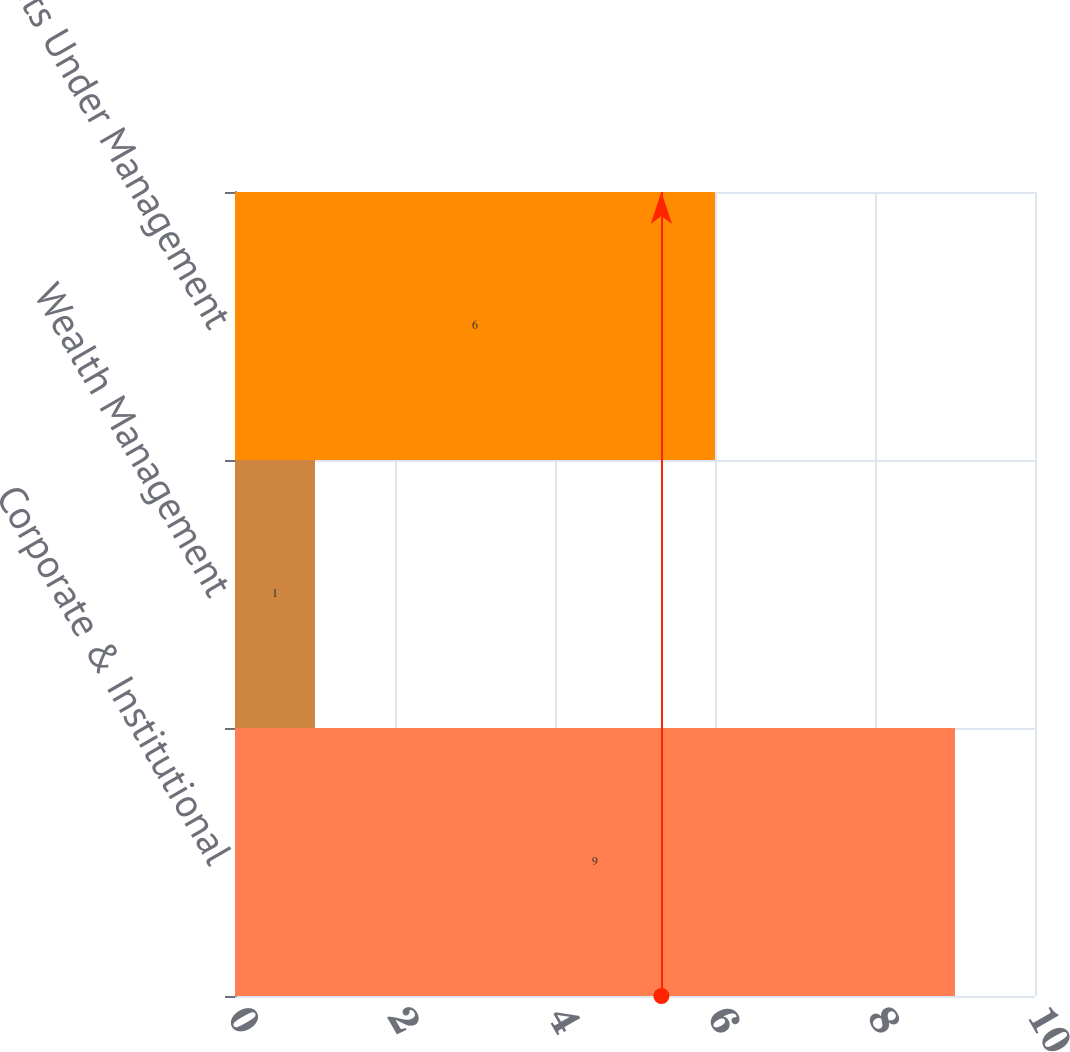Convert chart to OTSL. <chart><loc_0><loc_0><loc_500><loc_500><bar_chart><fcel>Corporate & Institutional<fcel>Wealth Management<fcel>Total Assets Under Management<nl><fcel>9<fcel>1<fcel>6<nl></chart> 